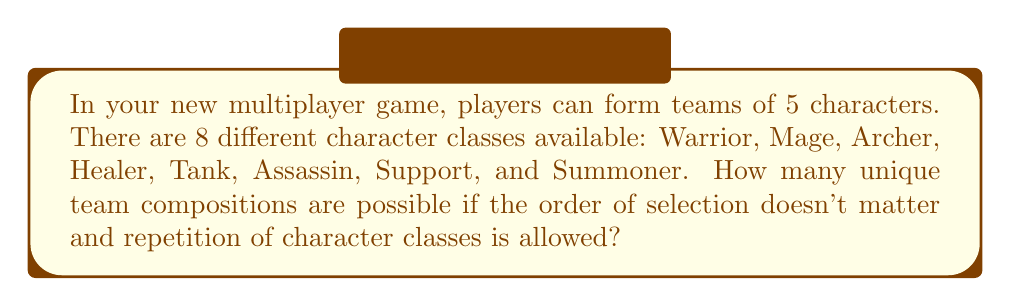Help me with this question. Let's approach this step-by-step:

1) This is a combination with repetition problem. We are selecting 5 characters from 8 classes, where the order doesn't matter and repetition is allowed.

2) The formula for combinations with repetition is:

   $$\binom{n+r-1}{r} = \binom{n+r-1}{n-1}$$

   Where $n$ is the number of types to choose from, and $r$ is the number of selections.

3) In this case:
   $n = 8$ (8 character classes)
   $r = 5$ (5 characters in a team)

4) Plugging these values into our formula:

   $$\binom{8+5-1}{5} = \binom{12}{5}$$

5) We can calculate this using the formula:

   $$\binom{12}{5} = \frac{12!}{5!(12-5)!} = \frac{12!}{5!7!}$$

6) Expanding this:
   
   $$\frac{12 * 11 * 10 * 9 * 8 * 7!}{(5 * 4 * 3 * 2 * 1) * 7!}$$

7) The 7! cancels out in the numerator and denominator:

   $$\frac{12 * 11 * 10 * 9 * 8}{5 * 4 * 3 * 2 * 1} = \frac{95040}{120} = 792$$

Therefore, there are 792 unique team compositions possible.
Answer: 792 